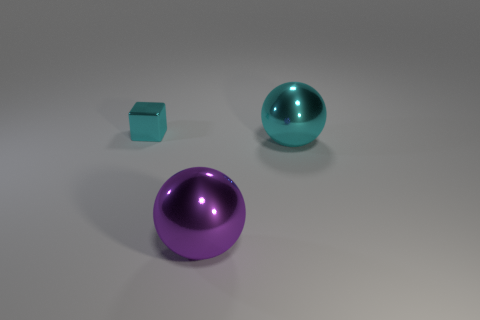How many objects are either small yellow things or big balls that are left of the cyan sphere?
Your answer should be very brief. 1. What shape is the other object that is the same color as the tiny thing?
Keep it short and to the point. Sphere. What is the small cube made of?
Provide a succinct answer. Metal. Is the cyan sphere made of the same material as the big purple ball?
Your answer should be very brief. Yes. How many metal objects are small cubes or big cyan objects?
Provide a succinct answer. 2. The object that is behind the big cyan sphere has what shape?
Your response must be concise. Cube. The other purple object that is made of the same material as the tiny thing is what size?
Provide a short and direct response. Large. The shiny object that is both behind the purple sphere and on the left side of the big cyan metal thing has what shape?
Keep it short and to the point. Cube. Does the shiny object that is on the right side of the purple thing have the same color as the metal cube?
Your answer should be very brief. Yes. Does the metallic object in front of the cyan metallic ball have the same shape as the cyan thing in front of the tiny cyan thing?
Your response must be concise. Yes. 